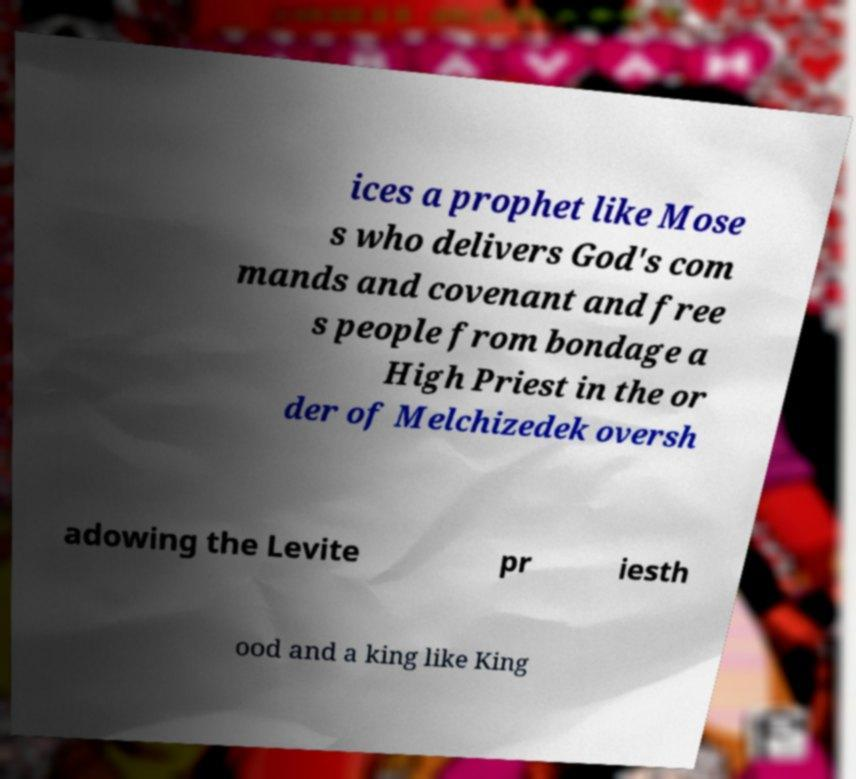I need the written content from this picture converted into text. Can you do that? ices a prophet like Mose s who delivers God's com mands and covenant and free s people from bondage a High Priest in the or der of Melchizedek oversh adowing the Levite pr iesth ood and a king like King 